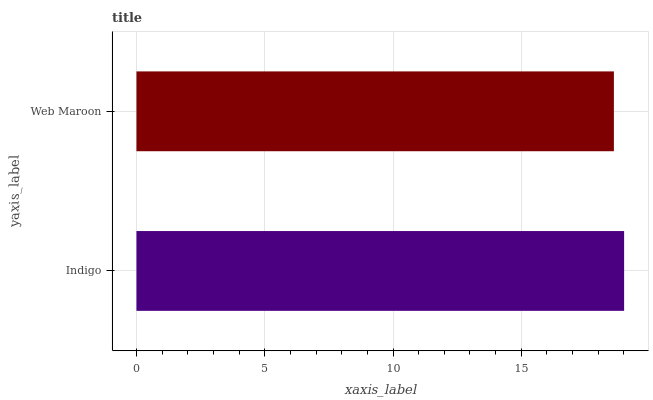Is Web Maroon the minimum?
Answer yes or no. Yes. Is Indigo the maximum?
Answer yes or no. Yes. Is Web Maroon the maximum?
Answer yes or no. No. Is Indigo greater than Web Maroon?
Answer yes or no. Yes. Is Web Maroon less than Indigo?
Answer yes or no. Yes. Is Web Maroon greater than Indigo?
Answer yes or no. No. Is Indigo less than Web Maroon?
Answer yes or no. No. Is Indigo the high median?
Answer yes or no. Yes. Is Web Maroon the low median?
Answer yes or no. Yes. Is Web Maroon the high median?
Answer yes or no. No. Is Indigo the low median?
Answer yes or no. No. 